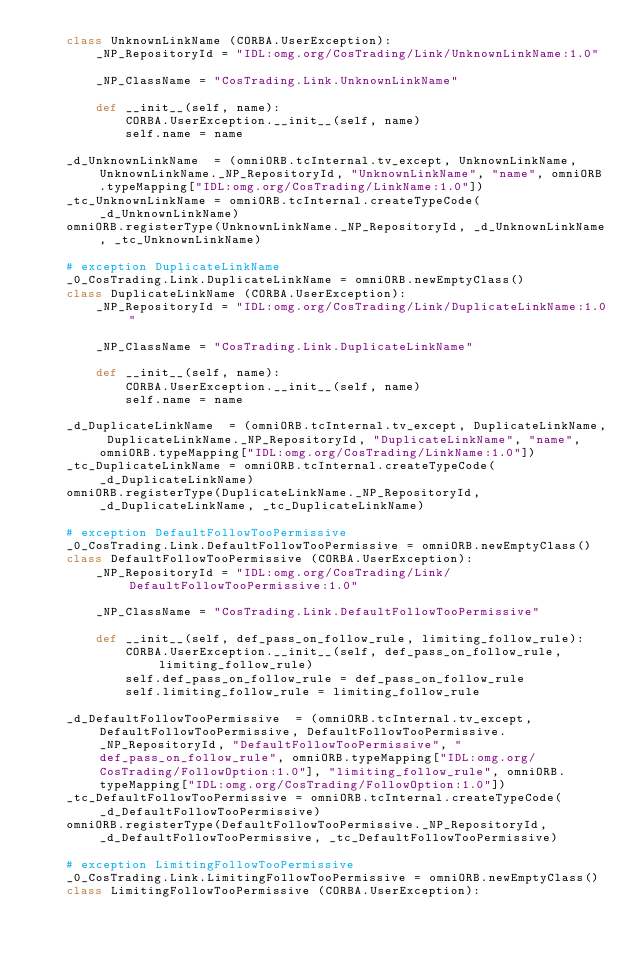Convert code to text. <code><loc_0><loc_0><loc_500><loc_500><_Python_>    class UnknownLinkName (CORBA.UserException):
        _NP_RepositoryId = "IDL:omg.org/CosTrading/Link/UnknownLinkName:1.0"

        _NP_ClassName = "CosTrading.Link.UnknownLinkName"

        def __init__(self, name):
            CORBA.UserException.__init__(self, name)
            self.name = name
    
    _d_UnknownLinkName  = (omniORB.tcInternal.tv_except, UnknownLinkName, UnknownLinkName._NP_RepositoryId, "UnknownLinkName", "name", omniORB.typeMapping["IDL:omg.org/CosTrading/LinkName:1.0"])
    _tc_UnknownLinkName = omniORB.tcInternal.createTypeCode(_d_UnknownLinkName)
    omniORB.registerType(UnknownLinkName._NP_RepositoryId, _d_UnknownLinkName, _tc_UnknownLinkName)
    
    # exception DuplicateLinkName
    _0_CosTrading.Link.DuplicateLinkName = omniORB.newEmptyClass()
    class DuplicateLinkName (CORBA.UserException):
        _NP_RepositoryId = "IDL:omg.org/CosTrading/Link/DuplicateLinkName:1.0"

        _NP_ClassName = "CosTrading.Link.DuplicateLinkName"

        def __init__(self, name):
            CORBA.UserException.__init__(self, name)
            self.name = name
    
    _d_DuplicateLinkName  = (omniORB.tcInternal.tv_except, DuplicateLinkName, DuplicateLinkName._NP_RepositoryId, "DuplicateLinkName", "name", omniORB.typeMapping["IDL:omg.org/CosTrading/LinkName:1.0"])
    _tc_DuplicateLinkName = omniORB.tcInternal.createTypeCode(_d_DuplicateLinkName)
    omniORB.registerType(DuplicateLinkName._NP_RepositoryId, _d_DuplicateLinkName, _tc_DuplicateLinkName)
    
    # exception DefaultFollowTooPermissive
    _0_CosTrading.Link.DefaultFollowTooPermissive = omniORB.newEmptyClass()
    class DefaultFollowTooPermissive (CORBA.UserException):
        _NP_RepositoryId = "IDL:omg.org/CosTrading/Link/DefaultFollowTooPermissive:1.0"

        _NP_ClassName = "CosTrading.Link.DefaultFollowTooPermissive"

        def __init__(self, def_pass_on_follow_rule, limiting_follow_rule):
            CORBA.UserException.__init__(self, def_pass_on_follow_rule, limiting_follow_rule)
            self.def_pass_on_follow_rule = def_pass_on_follow_rule
            self.limiting_follow_rule = limiting_follow_rule
    
    _d_DefaultFollowTooPermissive  = (omniORB.tcInternal.tv_except, DefaultFollowTooPermissive, DefaultFollowTooPermissive._NP_RepositoryId, "DefaultFollowTooPermissive", "def_pass_on_follow_rule", omniORB.typeMapping["IDL:omg.org/CosTrading/FollowOption:1.0"], "limiting_follow_rule", omniORB.typeMapping["IDL:omg.org/CosTrading/FollowOption:1.0"])
    _tc_DefaultFollowTooPermissive = omniORB.tcInternal.createTypeCode(_d_DefaultFollowTooPermissive)
    omniORB.registerType(DefaultFollowTooPermissive._NP_RepositoryId, _d_DefaultFollowTooPermissive, _tc_DefaultFollowTooPermissive)
    
    # exception LimitingFollowTooPermissive
    _0_CosTrading.Link.LimitingFollowTooPermissive = omniORB.newEmptyClass()
    class LimitingFollowTooPermissive (CORBA.UserException):</code> 